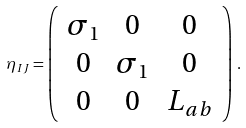Convert formula to latex. <formula><loc_0><loc_0><loc_500><loc_500>\eta _ { I J } = \left ( \begin{array} { c c c } \sigma _ { 1 } & 0 & 0 \\ 0 & \sigma _ { 1 } & 0 \\ 0 & 0 & L _ { a b } \end{array} \right ) \, .</formula> 